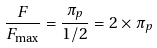Convert formula to latex. <formula><loc_0><loc_0><loc_500><loc_500>\frac { F } { F _ { \max } } = \frac { \pi _ { p } } { 1 / 2 } = 2 \times \pi _ { p }</formula> 